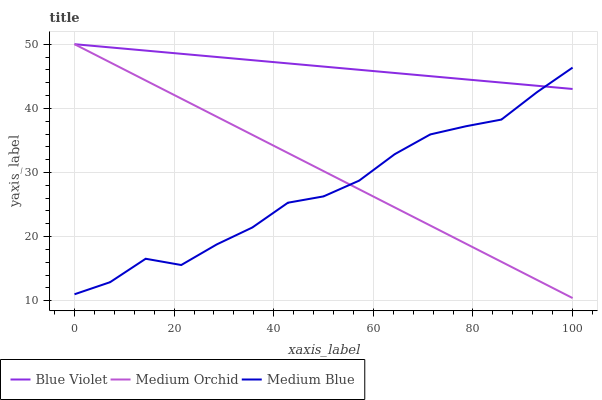Does Medium Blue have the minimum area under the curve?
Answer yes or no. Yes. Does Blue Violet have the maximum area under the curve?
Answer yes or no. Yes. Does Blue Violet have the minimum area under the curve?
Answer yes or no. No. Does Medium Blue have the maximum area under the curve?
Answer yes or no. No. Is Medium Orchid the smoothest?
Answer yes or no. Yes. Is Medium Blue the roughest?
Answer yes or no. Yes. Is Blue Violet the smoothest?
Answer yes or no. No. Is Blue Violet the roughest?
Answer yes or no. No. Does Medium Blue have the lowest value?
Answer yes or no. No. Does Medium Blue have the highest value?
Answer yes or no. No. 